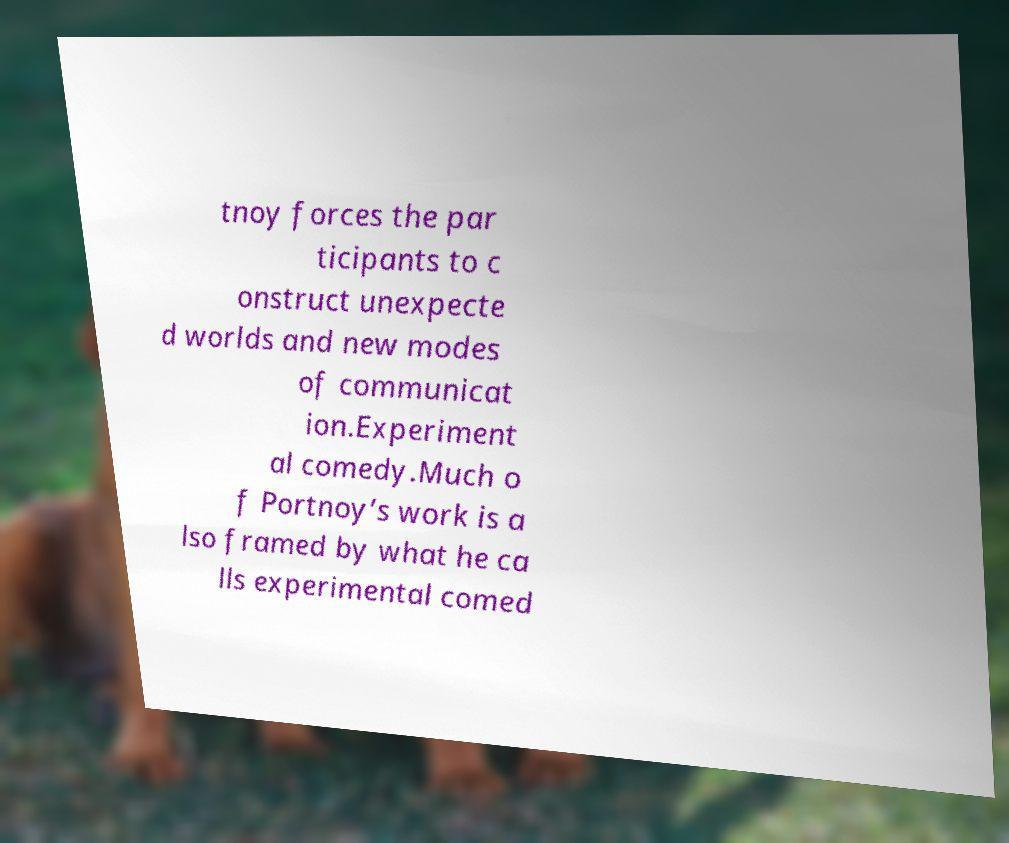Can you read and provide the text displayed in the image?This photo seems to have some interesting text. Can you extract and type it out for me? tnoy forces the par ticipants to c onstruct unexpecte d worlds and new modes of communicat ion.Experiment al comedy.Much o f Portnoy’s work is a lso framed by what he ca lls experimental comed 